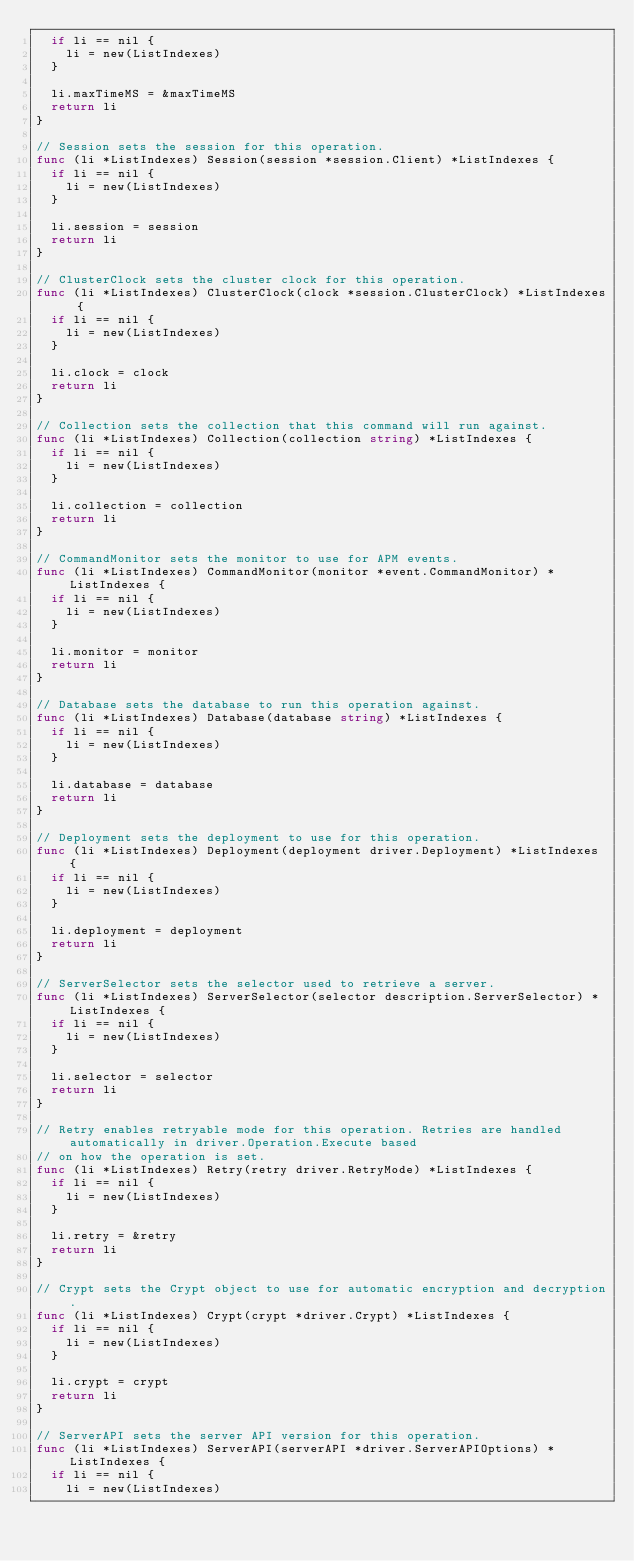<code> <loc_0><loc_0><loc_500><loc_500><_Go_>	if li == nil {
		li = new(ListIndexes)
	}

	li.maxTimeMS = &maxTimeMS
	return li
}

// Session sets the session for this operation.
func (li *ListIndexes) Session(session *session.Client) *ListIndexes {
	if li == nil {
		li = new(ListIndexes)
	}

	li.session = session
	return li
}

// ClusterClock sets the cluster clock for this operation.
func (li *ListIndexes) ClusterClock(clock *session.ClusterClock) *ListIndexes {
	if li == nil {
		li = new(ListIndexes)
	}

	li.clock = clock
	return li
}

// Collection sets the collection that this command will run against.
func (li *ListIndexes) Collection(collection string) *ListIndexes {
	if li == nil {
		li = new(ListIndexes)
	}

	li.collection = collection
	return li
}

// CommandMonitor sets the monitor to use for APM events.
func (li *ListIndexes) CommandMonitor(monitor *event.CommandMonitor) *ListIndexes {
	if li == nil {
		li = new(ListIndexes)
	}

	li.monitor = monitor
	return li
}

// Database sets the database to run this operation against.
func (li *ListIndexes) Database(database string) *ListIndexes {
	if li == nil {
		li = new(ListIndexes)
	}

	li.database = database
	return li
}

// Deployment sets the deployment to use for this operation.
func (li *ListIndexes) Deployment(deployment driver.Deployment) *ListIndexes {
	if li == nil {
		li = new(ListIndexes)
	}

	li.deployment = deployment
	return li
}

// ServerSelector sets the selector used to retrieve a server.
func (li *ListIndexes) ServerSelector(selector description.ServerSelector) *ListIndexes {
	if li == nil {
		li = new(ListIndexes)
	}

	li.selector = selector
	return li
}

// Retry enables retryable mode for this operation. Retries are handled automatically in driver.Operation.Execute based
// on how the operation is set.
func (li *ListIndexes) Retry(retry driver.RetryMode) *ListIndexes {
	if li == nil {
		li = new(ListIndexes)
	}

	li.retry = &retry
	return li
}

// Crypt sets the Crypt object to use for automatic encryption and decryption.
func (li *ListIndexes) Crypt(crypt *driver.Crypt) *ListIndexes {
	if li == nil {
		li = new(ListIndexes)
	}

	li.crypt = crypt
	return li
}

// ServerAPI sets the server API version for this operation.
func (li *ListIndexes) ServerAPI(serverAPI *driver.ServerAPIOptions) *ListIndexes {
	if li == nil {
		li = new(ListIndexes)</code> 